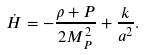Convert formula to latex. <formula><loc_0><loc_0><loc_500><loc_500>\dot { H } = - \frac { \rho + P } { 2 M _ { P } ^ { 2 } } + \frac { k } { a ^ { 2 } } .</formula> 